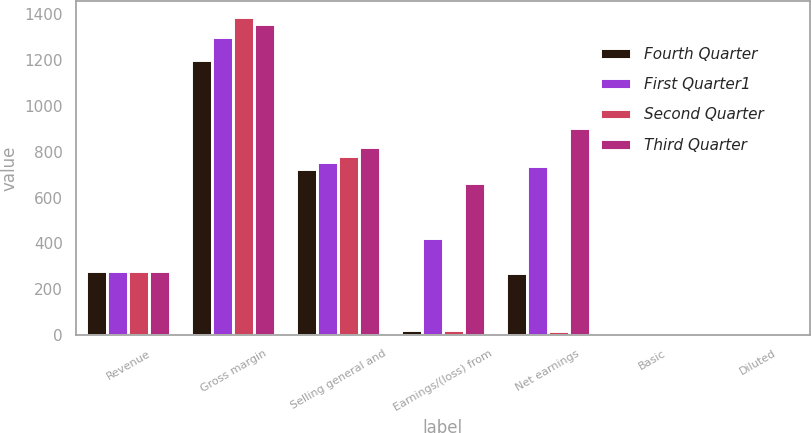Convert chart. <chart><loc_0><loc_0><loc_500><loc_500><stacked_bar_chart><ecel><fcel>Revenue<fcel>Gross margin<fcel>Selling general and<fcel>Earnings/(loss) from<fcel>Net earnings<fcel>Basic<fcel>Diluted<nl><fcel>Fourth Quarter<fcel>281.05<fcel>1200.5<fcel>725.4<fcel>20.7<fcel>270.7<fcel>0.72<fcel>0.71<nl><fcel>First Quarter1<fcel>281.05<fcel>1299.9<fcel>755.6<fcel>423.6<fcel>739.3<fcel>0.78<fcel>0.77<nl><fcel>Second Quarter<fcel>281.05<fcel>1387.5<fcel>781.7<fcel>23.9<fcel>19<fcel>0.01<fcel>0.01<nl><fcel>Third Quarter<fcel>281.05<fcel>1357.4<fcel>819.3<fcel>664.5<fcel>902.2<fcel>0.63<fcel>0.61<nl></chart> 